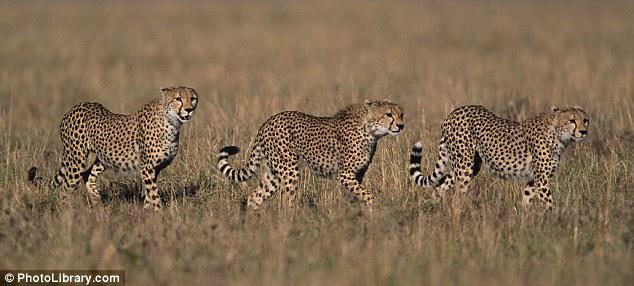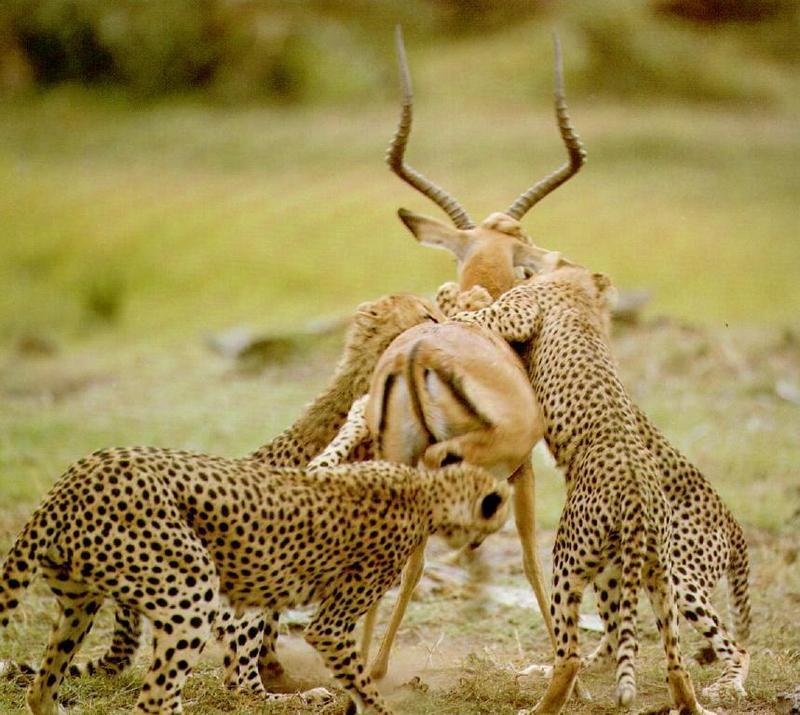The first image is the image on the left, the second image is the image on the right. For the images displayed, is the sentence "An image shows at least one cheetah near an animal with curved horns." factually correct? Answer yes or no. Yes. The first image is the image on the left, the second image is the image on the right. Considering the images on both sides, is "there are exactly three animals in the image on the right" valid? Answer yes or no. No. 